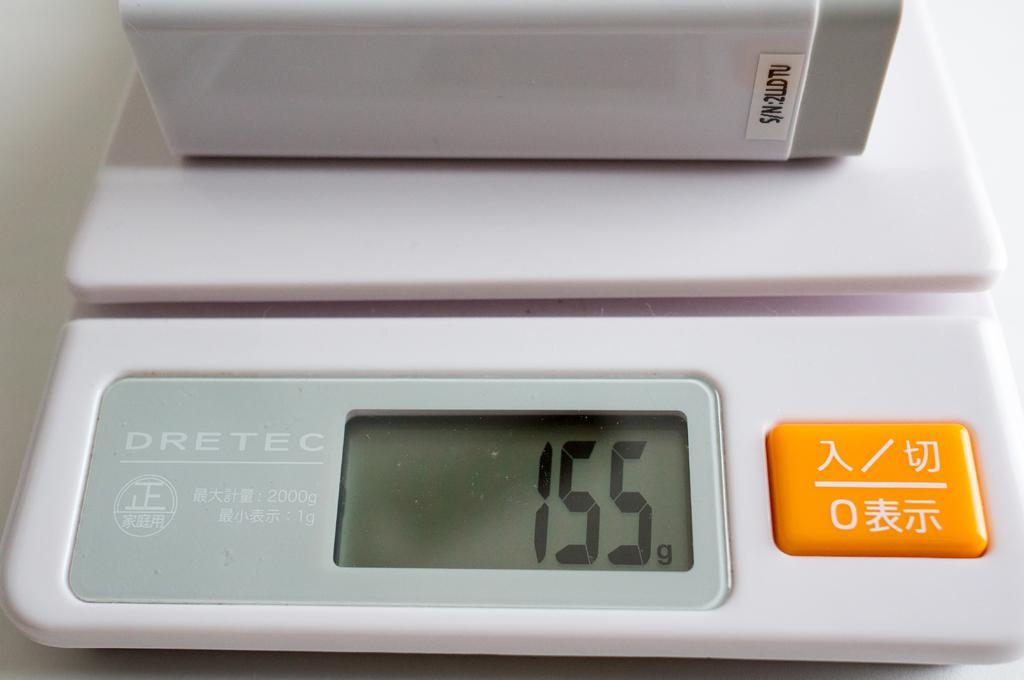Could you give a brief overview of what you see in this image? In this picture we can see a digital device with an orange button. 